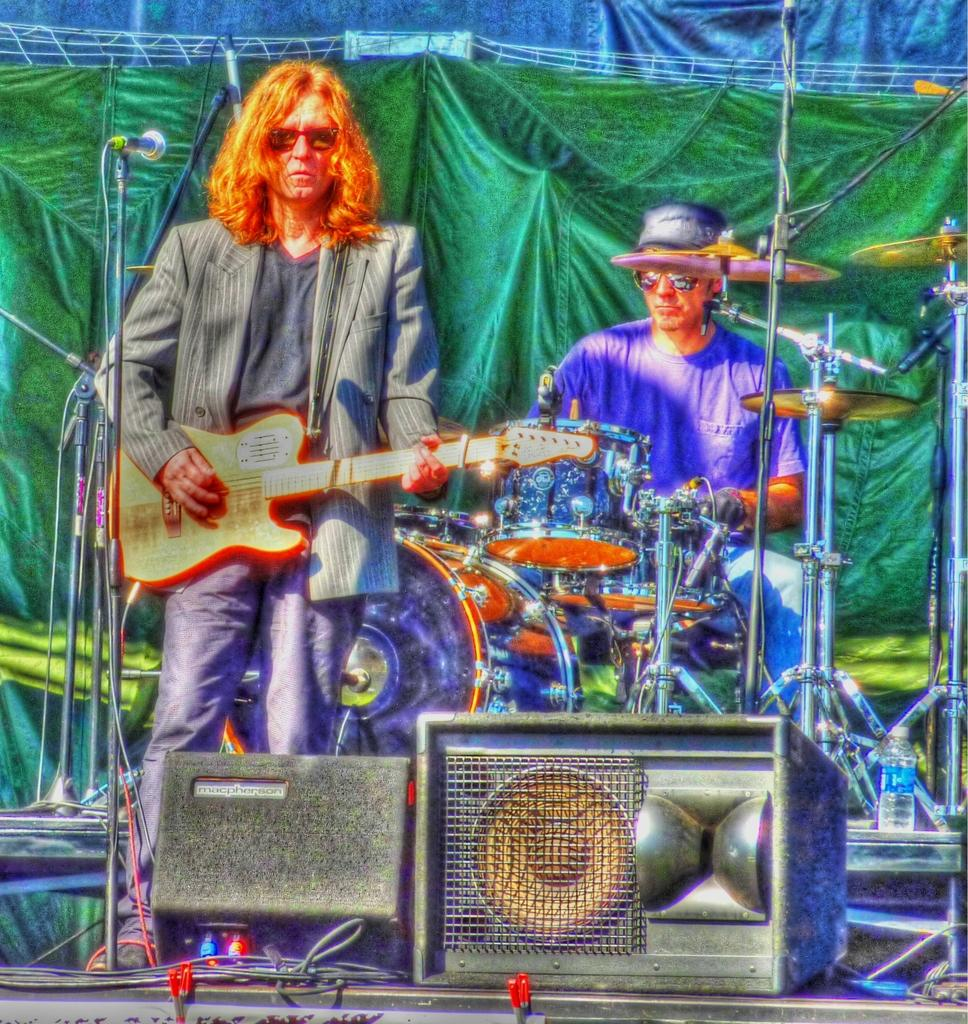What is the main activity being performed by the person in the image? There is a person playing a guitar in the image. Are there any other musicians in the image? Yes, there is another person playing a musical instrument in the image. What equipment is visible in the image that might be used for amplifying sound? Speakers are visible in the image. What devices are present in the image that might be used for capturing sound? Microphones are present in the image. What type of decoration can be seen in the background of the image? There are curtains in the background of the image. What object can be seen that might be used for holding a beverage? There is a bottle in the image. What type of copper material is being used to attack the guitar in the image? There is no copper material or attack being depicted in the image; it features people playing musical instruments with speakers and microphones present. 